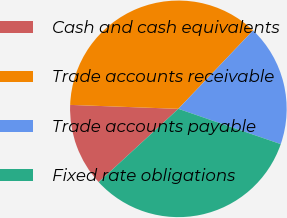Convert chart. <chart><loc_0><loc_0><loc_500><loc_500><pie_chart><fcel>Cash and cash equivalents<fcel>Trade accounts receivable<fcel>Trade accounts payable<fcel>Fixed rate obligations<nl><fcel>12.42%<fcel>36.54%<fcel>18.17%<fcel>32.88%<nl></chart> 